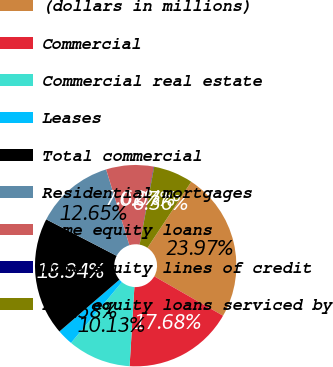<chart> <loc_0><loc_0><loc_500><loc_500><pie_chart><fcel>(dollars in millions)<fcel>Commercial<fcel>Commercial real estate<fcel>Leases<fcel>Total commercial<fcel>Residential mortgages<fcel>Home equity loans<fcel>Home equity lines of credit<fcel>Home equity loans serviced by<nl><fcel>23.97%<fcel>17.68%<fcel>10.13%<fcel>2.58%<fcel>18.94%<fcel>12.65%<fcel>7.62%<fcel>0.07%<fcel>6.36%<nl></chart> 